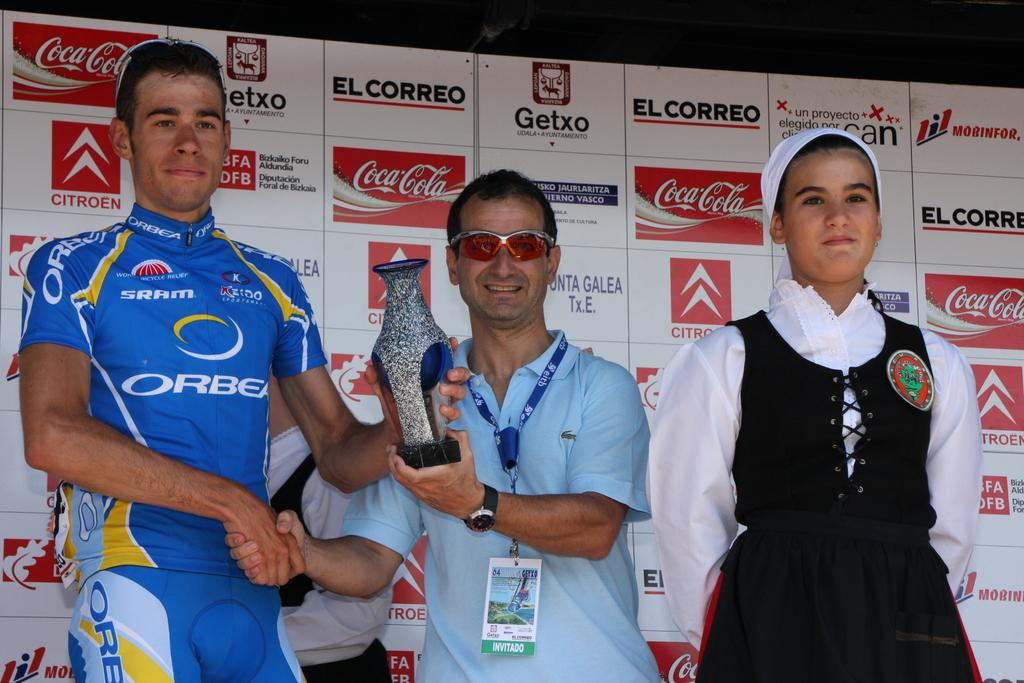<image>
Offer a succinct explanation of the picture presented. a Coca Cola logo behind the people standing together 